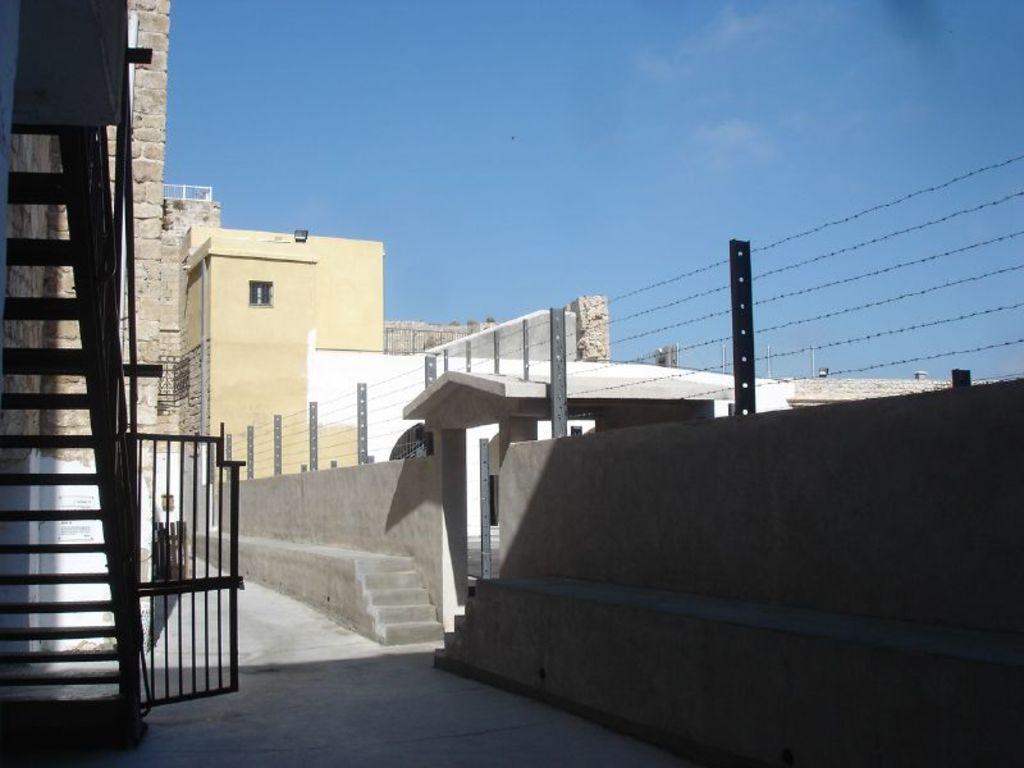How would you summarize this image in a sentence or two? At the bottom of the picture, we see the pavement. On the left side, we see the gate and the staircase. On the right side, we see a wall, staircase and the fence. There are buildings and poles in the background. At the top, we see the sky, which is blue in color. 